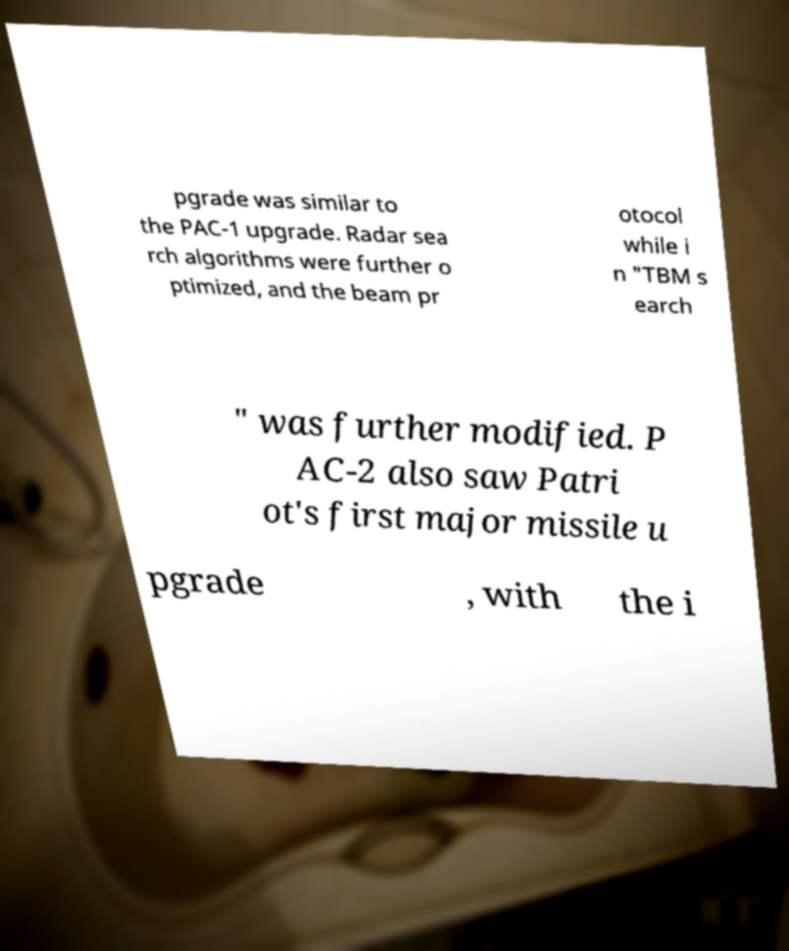Can you accurately transcribe the text from the provided image for me? pgrade was similar to the PAC-1 upgrade. Radar sea rch algorithms were further o ptimized, and the beam pr otocol while i n "TBM s earch " was further modified. P AC-2 also saw Patri ot's first major missile u pgrade , with the i 